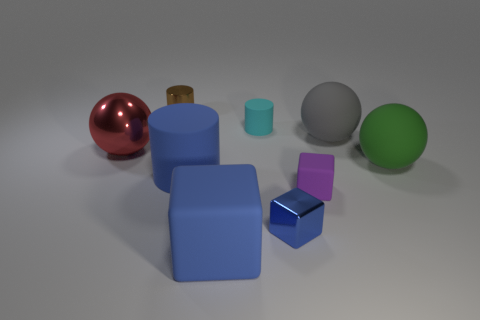There is a tiny metal thing that is in front of the large blue matte thing that is behind the purple thing; what is its color?
Ensure brevity in your answer.  Blue. Are there more small metal cylinders that are to the left of the purple thing than gray matte things that are in front of the gray object?
Give a very brief answer. Yes. Is the material of the ball that is on the right side of the large gray matte ball the same as the large ball that is on the left side of the purple block?
Your answer should be very brief. No. Are there any shiny things in front of the large red metal sphere?
Your answer should be very brief. Yes. What number of yellow objects are small metallic things or big rubber cubes?
Provide a short and direct response. 0. Does the gray sphere have the same material as the tiny cylinder that is in front of the brown object?
Provide a succinct answer. Yes. What size is the gray matte thing that is the same shape as the large red object?
Provide a succinct answer. Large. What is the material of the big red object?
Give a very brief answer. Metal. There is a cylinder in front of the cylinder on the right side of the blue matte object that is in front of the blue shiny object; what is its material?
Give a very brief answer. Rubber. There is a green object that is on the right side of the shiny sphere; is its size the same as the metal thing that is in front of the small rubber block?
Keep it short and to the point. No. 